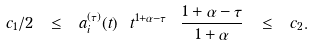Convert formula to latex. <formula><loc_0><loc_0><loc_500><loc_500>c _ { 1 } / 2 \ \leq \ a ^ { ( \tau ) } _ { i } ( t ) \ t ^ { 1 + \alpha - \tau } \ \frac { 1 + \alpha - \tau } { 1 + \alpha } \ \leq \ c _ { 2 } .</formula> 